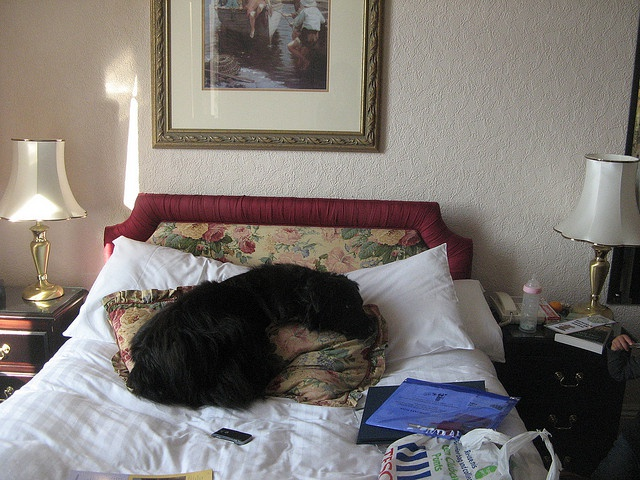Describe the objects in this image and their specific colors. I can see bed in gray, darkgray, lightgray, and maroon tones, dog in gray, black, and darkgray tones, book in gray, blue, navy, and black tones, people in gray, black, brown, and maroon tones, and book in gray and black tones in this image. 